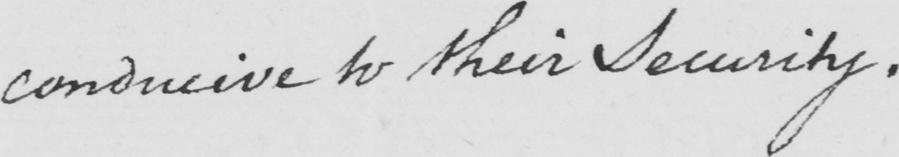What is written in this line of handwriting? conducive to their Security . 